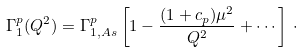<formula> <loc_0><loc_0><loc_500><loc_500>\Gamma _ { 1 } ^ { p } ( Q ^ { 2 } ) = \Gamma _ { 1 , A s } ^ { p } \left [ 1 - { \frac { ( 1 + c _ { p } ) \mu ^ { 2 } } { Q ^ { 2 } } } + \cdots \right ] \, \cdot</formula> 